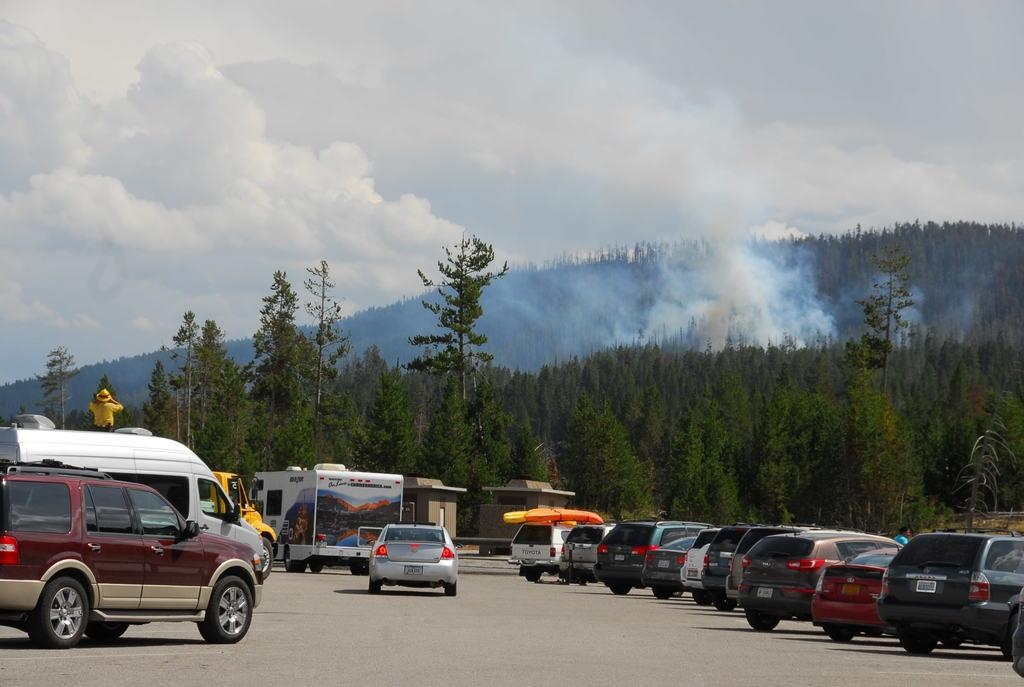What types of objects can be seen in the image? There are vehicles and a person standing in the image. What natural elements are present in the image? There are trees, clouds, and the sky visible in the image. Can you describe any atmospheric conditions in the image? There is smoke visible in the image. What type of growth is visible on the person's guitar in the image? There is no guitar present in the image, so there cannot be any growth on it. 